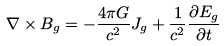Convert formula to latex. <formula><loc_0><loc_0><loc_500><loc_500>\nabla \times B _ { g } = - { \frac { 4 \pi G } { c ^ { 2 } } } J _ { g } + { \frac { 1 } { c ^ { 2 } } } { \frac { \partial E _ { g } } { \partial t } }</formula> 